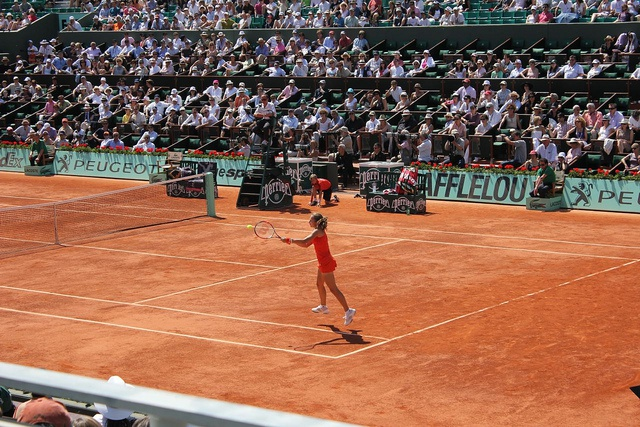Describe the objects in this image and their specific colors. I can see people in black, gray, darkgray, and maroon tones, chair in black, gray, teal, and darkgray tones, people in black, brown, and maroon tones, people in black, maroon, gray, and darkgray tones, and people in black, maroon, and brown tones in this image. 